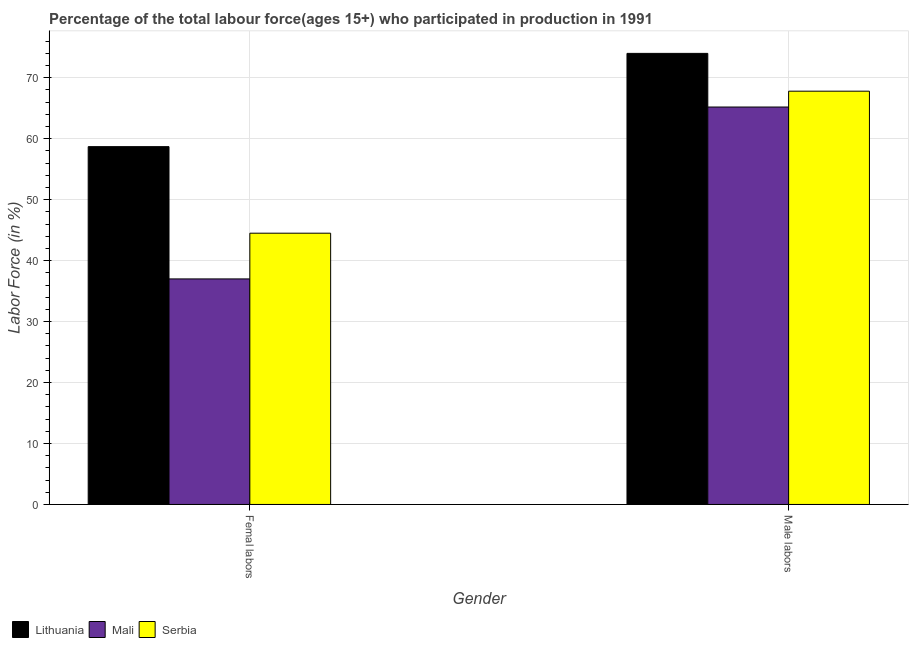How many different coloured bars are there?
Provide a short and direct response. 3. Are the number of bars per tick equal to the number of legend labels?
Offer a terse response. Yes. How many bars are there on the 1st tick from the left?
Your answer should be compact. 3. How many bars are there on the 2nd tick from the right?
Offer a very short reply. 3. What is the label of the 1st group of bars from the left?
Keep it short and to the point. Femal labors. What is the percentage of male labour force in Lithuania?
Ensure brevity in your answer.  74. Across all countries, what is the maximum percentage of female labor force?
Provide a succinct answer. 58.7. Across all countries, what is the minimum percentage of male labour force?
Make the answer very short. 65.2. In which country was the percentage of female labor force maximum?
Your answer should be very brief. Lithuania. In which country was the percentage of male labour force minimum?
Your answer should be very brief. Mali. What is the total percentage of male labour force in the graph?
Your answer should be compact. 207. What is the difference between the percentage of male labour force in Serbia and the percentage of female labor force in Lithuania?
Provide a short and direct response. 9.1. What is the average percentage of female labor force per country?
Give a very brief answer. 46.73. What is the difference between the percentage of male labour force and percentage of female labor force in Lithuania?
Provide a succinct answer. 15.3. In how many countries, is the percentage of female labor force greater than 16 %?
Offer a very short reply. 3. What is the ratio of the percentage of female labor force in Mali to that in Serbia?
Your answer should be compact. 0.83. Is the percentage of male labour force in Mali less than that in Lithuania?
Your answer should be compact. Yes. What does the 1st bar from the left in Male labors represents?
Offer a terse response. Lithuania. What does the 2nd bar from the right in Femal labors represents?
Make the answer very short. Mali. How many bars are there?
Offer a very short reply. 6. Are all the bars in the graph horizontal?
Ensure brevity in your answer.  No. How many countries are there in the graph?
Your answer should be compact. 3. Does the graph contain any zero values?
Offer a terse response. No. Does the graph contain grids?
Ensure brevity in your answer.  Yes. How many legend labels are there?
Ensure brevity in your answer.  3. What is the title of the graph?
Ensure brevity in your answer.  Percentage of the total labour force(ages 15+) who participated in production in 1991. What is the label or title of the X-axis?
Offer a terse response. Gender. What is the Labor Force (in %) in Lithuania in Femal labors?
Ensure brevity in your answer.  58.7. What is the Labor Force (in %) in Mali in Femal labors?
Keep it short and to the point. 37. What is the Labor Force (in %) of Serbia in Femal labors?
Give a very brief answer. 44.5. What is the Labor Force (in %) of Mali in Male labors?
Your answer should be very brief. 65.2. What is the Labor Force (in %) of Serbia in Male labors?
Provide a succinct answer. 67.8. Across all Gender, what is the maximum Labor Force (in %) of Mali?
Make the answer very short. 65.2. Across all Gender, what is the maximum Labor Force (in %) of Serbia?
Provide a short and direct response. 67.8. Across all Gender, what is the minimum Labor Force (in %) in Lithuania?
Provide a succinct answer. 58.7. Across all Gender, what is the minimum Labor Force (in %) in Serbia?
Your response must be concise. 44.5. What is the total Labor Force (in %) in Lithuania in the graph?
Make the answer very short. 132.7. What is the total Labor Force (in %) of Mali in the graph?
Your answer should be compact. 102.2. What is the total Labor Force (in %) of Serbia in the graph?
Provide a succinct answer. 112.3. What is the difference between the Labor Force (in %) in Lithuania in Femal labors and that in Male labors?
Your answer should be compact. -15.3. What is the difference between the Labor Force (in %) of Mali in Femal labors and that in Male labors?
Keep it short and to the point. -28.2. What is the difference between the Labor Force (in %) in Serbia in Femal labors and that in Male labors?
Make the answer very short. -23.3. What is the difference between the Labor Force (in %) of Lithuania in Femal labors and the Labor Force (in %) of Mali in Male labors?
Your answer should be very brief. -6.5. What is the difference between the Labor Force (in %) of Lithuania in Femal labors and the Labor Force (in %) of Serbia in Male labors?
Your answer should be very brief. -9.1. What is the difference between the Labor Force (in %) of Mali in Femal labors and the Labor Force (in %) of Serbia in Male labors?
Your answer should be very brief. -30.8. What is the average Labor Force (in %) of Lithuania per Gender?
Your answer should be compact. 66.35. What is the average Labor Force (in %) of Mali per Gender?
Offer a terse response. 51.1. What is the average Labor Force (in %) in Serbia per Gender?
Make the answer very short. 56.15. What is the difference between the Labor Force (in %) of Lithuania and Labor Force (in %) of Mali in Femal labors?
Offer a very short reply. 21.7. What is the difference between the Labor Force (in %) of Lithuania and Labor Force (in %) of Serbia in Male labors?
Make the answer very short. 6.2. What is the ratio of the Labor Force (in %) in Lithuania in Femal labors to that in Male labors?
Keep it short and to the point. 0.79. What is the ratio of the Labor Force (in %) of Mali in Femal labors to that in Male labors?
Offer a terse response. 0.57. What is the ratio of the Labor Force (in %) in Serbia in Femal labors to that in Male labors?
Offer a very short reply. 0.66. What is the difference between the highest and the second highest Labor Force (in %) of Mali?
Make the answer very short. 28.2. What is the difference between the highest and the second highest Labor Force (in %) in Serbia?
Ensure brevity in your answer.  23.3. What is the difference between the highest and the lowest Labor Force (in %) in Mali?
Your answer should be very brief. 28.2. What is the difference between the highest and the lowest Labor Force (in %) of Serbia?
Offer a terse response. 23.3. 